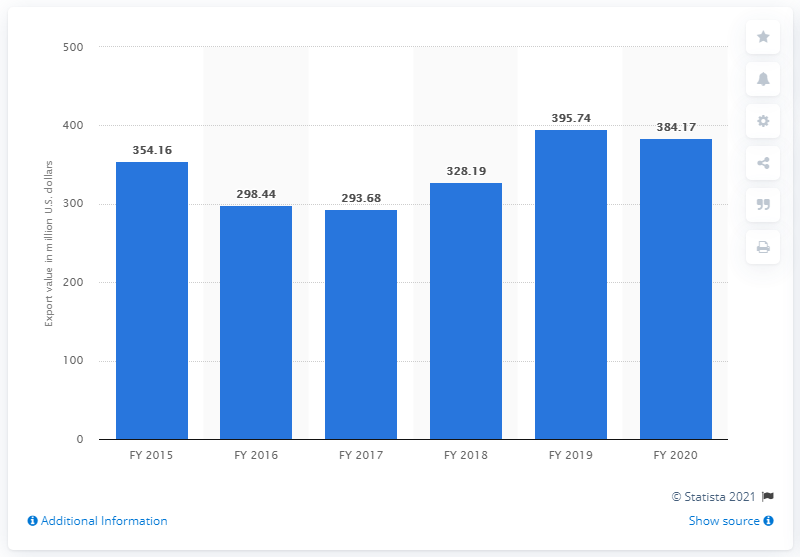Specify some key components in this picture. In the fiscal year of 2020, the export value of bicycles from India was 384.17 million. The export value of bicycles from India in fiscal year 2015 was approximately 354.16 million dollars. 